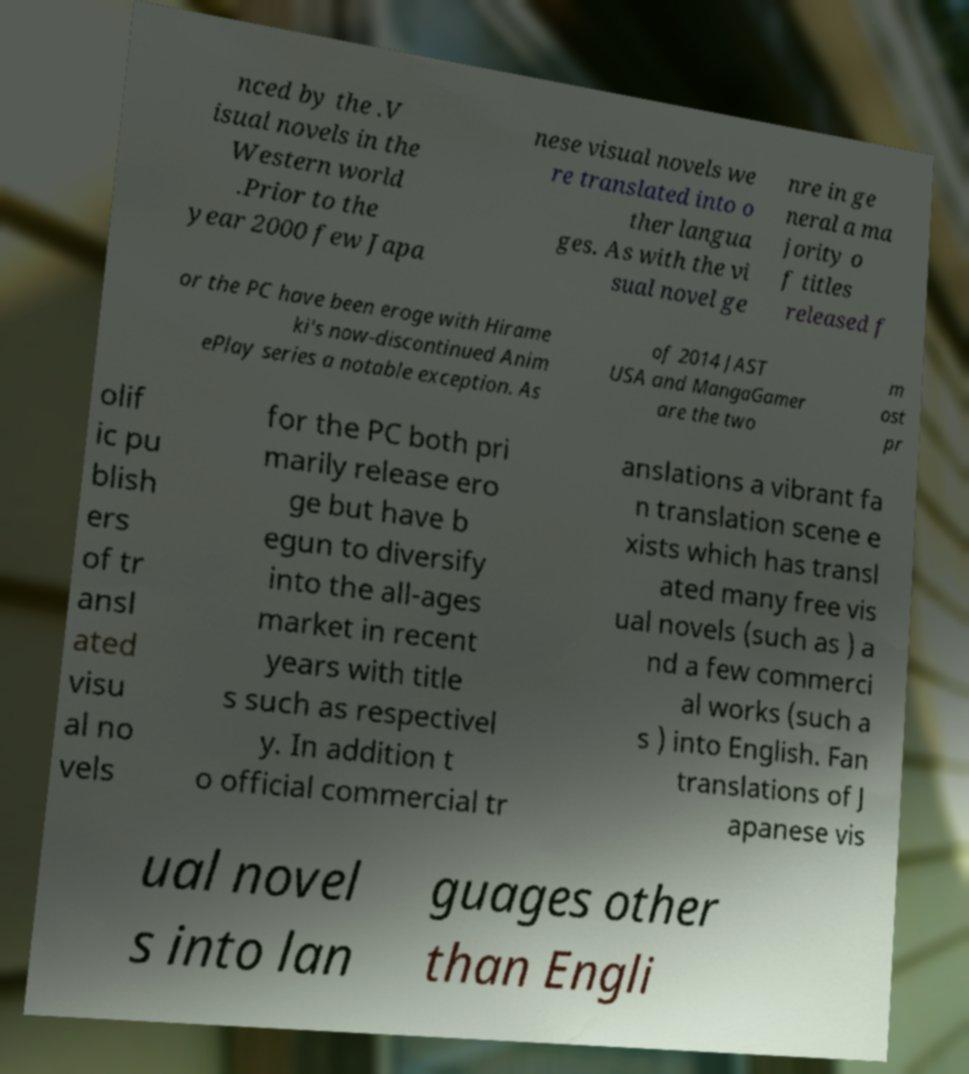Could you extract and type out the text from this image? nced by the .V isual novels in the Western world .Prior to the year 2000 few Japa nese visual novels we re translated into o ther langua ges. As with the vi sual novel ge nre in ge neral a ma jority o f titles released f or the PC have been eroge with Hirame ki's now-discontinued Anim ePlay series a notable exception. As of 2014 JAST USA and MangaGamer are the two m ost pr olif ic pu blish ers of tr ansl ated visu al no vels for the PC both pri marily release ero ge but have b egun to diversify into the all-ages market in recent years with title s such as respectivel y. In addition t o official commercial tr anslations a vibrant fa n translation scene e xists which has transl ated many free vis ual novels (such as ) a nd a few commerci al works (such a s ) into English. Fan translations of J apanese vis ual novel s into lan guages other than Engli 